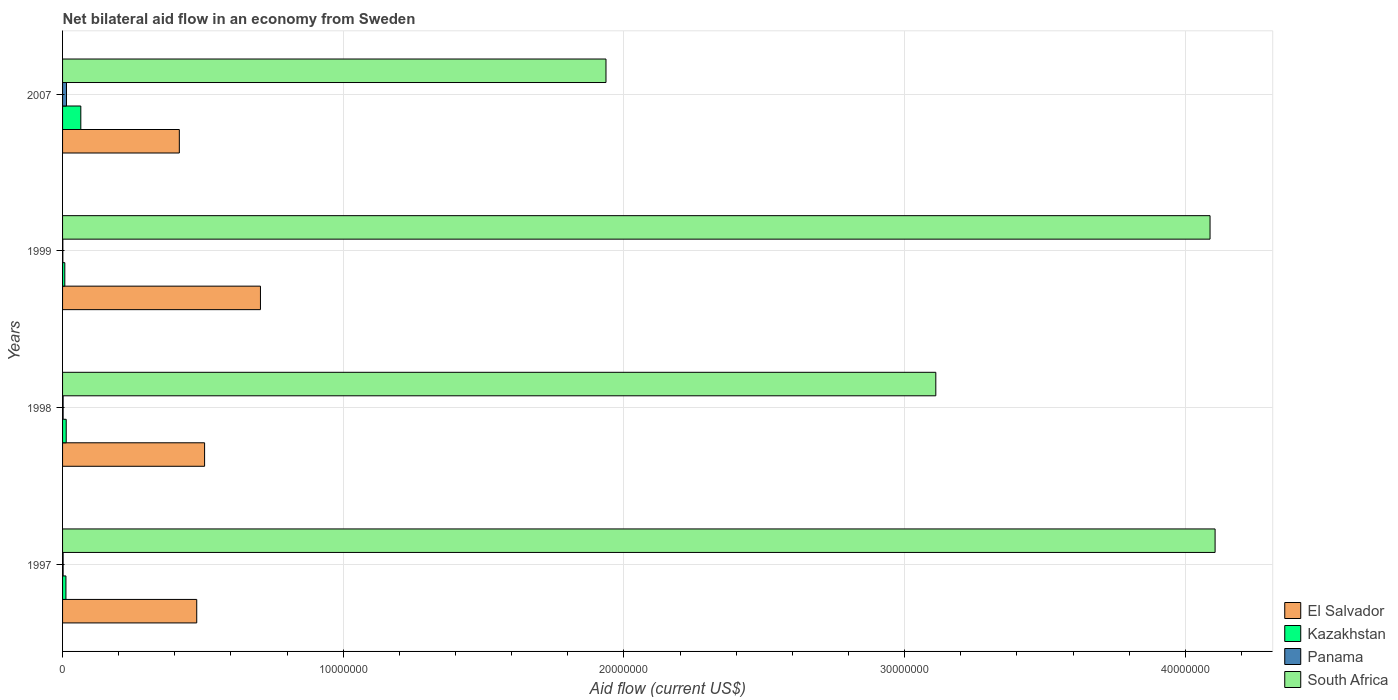How many bars are there on the 1st tick from the bottom?
Offer a very short reply. 4. What is the net bilateral aid flow in El Salvador in 1998?
Provide a succinct answer. 5.06e+06. Across all years, what is the maximum net bilateral aid flow in Panama?
Provide a succinct answer. 1.40e+05. What is the total net bilateral aid flow in Kazakhstan in the graph?
Provide a succinct answer. 9.80e+05. What is the difference between the net bilateral aid flow in South Africa in 1998 and the net bilateral aid flow in Kazakhstan in 1997?
Give a very brief answer. 3.10e+07. What is the average net bilateral aid flow in South Africa per year?
Give a very brief answer. 3.31e+07. In the year 1998, what is the difference between the net bilateral aid flow in Kazakhstan and net bilateral aid flow in El Salvador?
Your response must be concise. -4.93e+06. What is the ratio of the net bilateral aid flow in El Salvador in 1997 to that in 2007?
Ensure brevity in your answer.  1.15. Is the difference between the net bilateral aid flow in Kazakhstan in 1997 and 1999 greater than the difference between the net bilateral aid flow in El Salvador in 1997 and 1999?
Provide a succinct answer. Yes. What is the difference between the highest and the second highest net bilateral aid flow in Panama?
Ensure brevity in your answer.  1.20e+05. What is the difference between the highest and the lowest net bilateral aid flow in South Africa?
Make the answer very short. 2.17e+07. Is the sum of the net bilateral aid flow in South Africa in 1999 and 2007 greater than the maximum net bilateral aid flow in El Salvador across all years?
Your answer should be compact. Yes. Is it the case that in every year, the sum of the net bilateral aid flow in Panama and net bilateral aid flow in South Africa is greater than the sum of net bilateral aid flow in El Salvador and net bilateral aid flow in Kazakhstan?
Keep it short and to the point. Yes. What does the 3rd bar from the top in 1999 represents?
Ensure brevity in your answer.  Kazakhstan. What does the 1st bar from the bottom in 1997 represents?
Provide a succinct answer. El Salvador. Is it the case that in every year, the sum of the net bilateral aid flow in El Salvador and net bilateral aid flow in Panama is greater than the net bilateral aid flow in Kazakhstan?
Provide a short and direct response. Yes. Are all the bars in the graph horizontal?
Offer a terse response. Yes. What is the difference between two consecutive major ticks on the X-axis?
Provide a succinct answer. 1.00e+07. Are the values on the major ticks of X-axis written in scientific E-notation?
Keep it short and to the point. No. Does the graph contain any zero values?
Your response must be concise. No. Does the graph contain grids?
Offer a very short reply. Yes. What is the title of the graph?
Make the answer very short. Net bilateral aid flow in an economy from Sweden. What is the label or title of the X-axis?
Provide a short and direct response. Aid flow (current US$). What is the Aid flow (current US$) in El Salvador in 1997?
Offer a very short reply. 4.78e+06. What is the Aid flow (current US$) of South Africa in 1997?
Your answer should be compact. 4.11e+07. What is the Aid flow (current US$) in El Salvador in 1998?
Keep it short and to the point. 5.06e+06. What is the Aid flow (current US$) in Kazakhstan in 1998?
Provide a succinct answer. 1.30e+05. What is the Aid flow (current US$) in South Africa in 1998?
Your answer should be compact. 3.11e+07. What is the Aid flow (current US$) in El Salvador in 1999?
Your response must be concise. 7.05e+06. What is the Aid flow (current US$) in South Africa in 1999?
Offer a very short reply. 4.09e+07. What is the Aid flow (current US$) in El Salvador in 2007?
Give a very brief answer. 4.16e+06. What is the Aid flow (current US$) in Kazakhstan in 2007?
Provide a short and direct response. 6.50e+05. What is the Aid flow (current US$) in South Africa in 2007?
Provide a short and direct response. 1.94e+07. Across all years, what is the maximum Aid flow (current US$) in El Salvador?
Your answer should be very brief. 7.05e+06. Across all years, what is the maximum Aid flow (current US$) of Kazakhstan?
Provide a short and direct response. 6.50e+05. Across all years, what is the maximum Aid flow (current US$) in Panama?
Provide a short and direct response. 1.40e+05. Across all years, what is the maximum Aid flow (current US$) of South Africa?
Keep it short and to the point. 4.11e+07. Across all years, what is the minimum Aid flow (current US$) in El Salvador?
Your answer should be very brief. 4.16e+06. Across all years, what is the minimum Aid flow (current US$) in Kazakhstan?
Offer a terse response. 8.00e+04. Across all years, what is the minimum Aid flow (current US$) of South Africa?
Provide a short and direct response. 1.94e+07. What is the total Aid flow (current US$) in El Salvador in the graph?
Your answer should be very brief. 2.10e+07. What is the total Aid flow (current US$) of Kazakhstan in the graph?
Give a very brief answer. 9.80e+05. What is the total Aid flow (current US$) of Panama in the graph?
Keep it short and to the point. 1.90e+05. What is the total Aid flow (current US$) in South Africa in the graph?
Offer a terse response. 1.32e+08. What is the difference between the Aid flow (current US$) in El Salvador in 1997 and that in 1998?
Your response must be concise. -2.80e+05. What is the difference between the Aid flow (current US$) of Panama in 1997 and that in 1998?
Provide a succinct answer. 0. What is the difference between the Aid flow (current US$) of South Africa in 1997 and that in 1998?
Provide a succinct answer. 9.95e+06. What is the difference between the Aid flow (current US$) in El Salvador in 1997 and that in 1999?
Your response must be concise. -2.27e+06. What is the difference between the Aid flow (current US$) in El Salvador in 1997 and that in 2007?
Provide a short and direct response. 6.20e+05. What is the difference between the Aid flow (current US$) of Kazakhstan in 1997 and that in 2007?
Provide a succinct answer. -5.30e+05. What is the difference between the Aid flow (current US$) in Panama in 1997 and that in 2007?
Offer a terse response. -1.20e+05. What is the difference between the Aid flow (current US$) of South Africa in 1997 and that in 2007?
Ensure brevity in your answer.  2.17e+07. What is the difference between the Aid flow (current US$) of El Salvador in 1998 and that in 1999?
Offer a terse response. -1.99e+06. What is the difference between the Aid flow (current US$) in Kazakhstan in 1998 and that in 1999?
Your response must be concise. 5.00e+04. What is the difference between the Aid flow (current US$) of Panama in 1998 and that in 1999?
Provide a short and direct response. 10000. What is the difference between the Aid flow (current US$) of South Africa in 1998 and that in 1999?
Offer a terse response. -9.77e+06. What is the difference between the Aid flow (current US$) of El Salvador in 1998 and that in 2007?
Make the answer very short. 9.00e+05. What is the difference between the Aid flow (current US$) of Kazakhstan in 1998 and that in 2007?
Offer a terse response. -5.20e+05. What is the difference between the Aid flow (current US$) in Panama in 1998 and that in 2007?
Ensure brevity in your answer.  -1.20e+05. What is the difference between the Aid flow (current US$) in South Africa in 1998 and that in 2007?
Give a very brief answer. 1.18e+07. What is the difference between the Aid flow (current US$) in El Salvador in 1999 and that in 2007?
Ensure brevity in your answer.  2.89e+06. What is the difference between the Aid flow (current US$) of Kazakhstan in 1999 and that in 2007?
Offer a very short reply. -5.70e+05. What is the difference between the Aid flow (current US$) in Panama in 1999 and that in 2007?
Make the answer very short. -1.30e+05. What is the difference between the Aid flow (current US$) in South Africa in 1999 and that in 2007?
Give a very brief answer. 2.15e+07. What is the difference between the Aid flow (current US$) in El Salvador in 1997 and the Aid flow (current US$) in Kazakhstan in 1998?
Your response must be concise. 4.65e+06. What is the difference between the Aid flow (current US$) in El Salvador in 1997 and the Aid flow (current US$) in Panama in 1998?
Your response must be concise. 4.76e+06. What is the difference between the Aid flow (current US$) in El Salvador in 1997 and the Aid flow (current US$) in South Africa in 1998?
Your answer should be very brief. -2.63e+07. What is the difference between the Aid flow (current US$) in Kazakhstan in 1997 and the Aid flow (current US$) in South Africa in 1998?
Make the answer very short. -3.10e+07. What is the difference between the Aid flow (current US$) of Panama in 1997 and the Aid flow (current US$) of South Africa in 1998?
Offer a very short reply. -3.11e+07. What is the difference between the Aid flow (current US$) of El Salvador in 1997 and the Aid flow (current US$) of Kazakhstan in 1999?
Give a very brief answer. 4.70e+06. What is the difference between the Aid flow (current US$) in El Salvador in 1997 and the Aid flow (current US$) in Panama in 1999?
Offer a terse response. 4.77e+06. What is the difference between the Aid flow (current US$) of El Salvador in 1997 and the Aid flow (current US$) of South Africa in 1999?
Give a very brief answer. -3.61e+07. What is the difference between the Aid flow (current US$) of Kazakhstan in 1997 and the Aid flow (current US$) of South Africa in 1999?
Your response must be concise. -4.08e+07. What is the difference between the Aid flow (current US$) in Panama in 1997 and the Aid flow (current US$) in South Africa in 1999?
Your answer should be compact. -4.09e+07. What is the difference between the Aid flow (current US$) in El Salvador in 1997 and the Aid flow (current US$) in Kazakhstan in 2007?
Provide a short and direct response. 4.13e+06. What is the difference between the Aid flow (current US$) of El Salvador in 1997 and the Aid flow (current US$) of Panama in 2007?
Your answer should be compact. 4.64e+06. What is the difference between the Aid flow (current US$) of El Salvador in 1997 and the Aid flow (current US$) of South Africa in 2007?
Offer a terse response. -1.46e+07. What is the difference between the Aid flow (current US$) of Kazakhstan in 1997 and the Aid flow (current US$) of South Africa in 2007?
Make the answer very short. -1.92e+07. What is the difference between the Aid flow (current US$) in Panama in 1997 and the Aid flow (current US$) in South Africa in 2007?
Your answer should be compact. -1.93e+07. What is the difference between the Aid flow (current US$) in El Salvador in 1998 and the Aid flow (current US$) in Kazakhstan in 1999?
Make the answer very short. 4.98e+06. What is the difference between the Aid flow (current US$) in El Salvador in 1998 and the Aid flow (current US$) in Panama in 1999?
Offer a very short reply. 5.05e+06. What is the difference between the Aid flow (current US$) of El Salvador in 1998 and the Aid flow (current US$) of South Africa in 1999?
Your answer should be very brief. -3.58e+07. What is the difference between the Aid flow (current US$) in Kazakhstan in 1998 and the Aid flow (current US$) in South Africa in 1999?
Make the answer very short. -4.08e+07. What is the difference between the Aid flow (current US$) in Panama in 1998 and the Aid flow (current US$) in South Africa in 1999?
Offer a terse response. -4.09e+07. What is the difference between the Aid flow (current US$) in El Salvador in 1998 and the Aid flow (current US$) in Kazakhstan in 2007?
Your answer should be very brief. 4.41e+06. What is the difference between the Aid flow (current US$) in El Salvador in 1998 and the Aid flow (current US$) in Panama in 2007?
Offer a terse response. 4.92e+06. What is the difference between the Aid flow (current US$) of El Salvador in 1998 and the Aid flow (current US$) of South Africa in 2007?
Give a very brief answer. -1.43e+07. What is the difference between the Aid flow (current US$) in Kazakhstan in 1998 and the Aid flow (current US$) in Panama in 2007?
Provide a short and direct response. -10000. What is the difference between the Aid flow (current US$) of Kazakhstan in 1998 and the Aid flow (current US$) of South Africa in 2007?
Provide a short and direct response. -1.92e+07. What is the difference between the Aid flow (current US$) in Panama in 1998 and the Aid flow (current US$) in South Africa in 2007?
Keep it short and to the point. -1.93e+07. What is the difference between the Aid flow (current US$) in El Salvador in 1999 and the Aid flow (current US$) in Kazakhstan in 2007?
Your response must be concise. 6.40e+06. What is the difference between the Aid flow (current US$) of El Salvador in 1999 and the Aid flow (current US$) of Panama in 2007?
Provide a short and direct response. 6.91e+06. What is the difference between the Aid flow (current US$) in El Salvador in 1999 and the Aid flow (current US$) in South Africa in 2007?
Your answer should be compact. -1.23e+07. What is the difference between the Aid flow (current US$) of Kazakhstan in 1999 and the Aid flow (current US$) of South Africa in 2007?
Ensure brevity in your answer.  -1.93e+07. What is the difference between the Aid flow (current US$) of Panama in 1999 and the Aid flow (current US$) of South Africa in 2007?
Make the answer very short. -1.94e+07. What is the average Aid flow (current US$) of El Salvador per year?
Offer a terse response. 5.26e+06. What is the average Aid flow (current US$) in Kazakhstan per year?
Make the answer very short. 2.45e+05. What is the average Aid flow (current US$) of Panama per year?
Ensure brevity in your answer.  4.75e+04. What is the average Aid flow (current US$) of South Africa per year?
Ensure brevity in your answer.  3.31e+07. In the year 1997, what is the difference between the Aid flow (current US$) in El Salvador and Aid flow (current US$) in Kazakhstan?
Keep it short and to the point. 4.66e+06. In the year 1997, what is the difference between the Aid flow (current US$) in El Salvador and Aid flow (current US$) in Panama?
Provide a short and direct response. 4.76e+06. In the year 1997, what is the difference between the Aid flow (current US$) in El Salvador and Aid flow (current US$) in South Africa?
Your answer should be very brief. -3.63e+07. In the year 1997, what is the difference between the Aid flow (current US$) of Kazakhstan and Aid flow (current US$) of Panama?
Offer a terse response. 1.00e+05. In the year 1997, what is the difference between the Aid flow (current US$) of Kazakhstan and Aid flow (current US$) of South Africa?
Provide a succinct answer. -4.09e+07. In the year 1997, what is the difference between the Aid flow (current US$) in Panama and Aid flow (current US$) in South Africa?
Provide a short and direct response. -4.10e+07. In the year 1998, what is the difference between the Aid flow (current US$) of El Salvador and Aid flow (current US$) of Kazakhstan?
Your response must be concise. 4.93e+06. In the year 1998, what is the difference between the Aid flow (current US$) in El Salvador and Aid flow (current US$) in Panama?
Make the answer very short. 5.04e+06. In the year 1998, what is the difference between the Aid flow (current US$) in El Salvador and Aid flow (current US$) in South Africa?
Keep it short and to the point. -2.60e+07. In the year 1998, what is the difference between the Aid flow (current US$) in Kazakhstan and Aid flow (current US$) in South Africa?
Make the answer very short. -3.10e+07. In the year 1998, what is the difference between the Aid flow (current US$) in Panama and Aid flow (current US$) in South Africa?
Make the answer very short. -3.11e+07. In the year 1999, what is the difference between the Aid flow (current US$) of El Salvador and Aid flow (current US$) of Kazakhstan?
Give a very brief answer. 6.97e+06. In the year 1999, what is the difference between the Aid flow (current US$) of El Salvador and Aid flow (current US$) of Panama?
Keep it short and to the point. 7.04e+06. In the year 1999, what is the difference between the Aid flow (current US$) in El Salvador and Aid flow (current US$) in South Africa?
Offer a terse response. -3.38e+07. In the year 1999, what is the difference between the Aid flow (current US$) in Kazakhstan and Aid flow (current US$) in South Africa?
Offer a terse response. -4.08e+07. In the year 1999, what is the difference between the Aid flow (current US$) of Panama and Aid flow (current US$) of South Africa?
Your answer should be very brief. -4.09e+07. In the year 2007, what is the difference between the Aid flow (current US$) of El Salvador and Aid flow (current US$) of Kazakhstan?
Offer a terse response. 3.51e+06. In the year 2007, what is the difference between the Aid flow (current US$) of El Salvador and Aid flow (current US$) of Panama?
Ensure brevity in your answer.  4.02e+06. In the year 2007, what is the difference between the Aid flow (current US$) in El Salvador and Aid flow (current US$) in South Africa?
Provide a succinct answer. -1.52e+07. In the year 2007, what is the difference between the Aid flow (current US$) of Kazakhstan and Aid flow (current US$) of Panama?
Your answer should be very brief. 5.10e+05. In the year 2007, what is the difference between the Aid flow (current US$) in Kazakhstan and Aid flow (current US$) in South Africa?
Offer a very short reply. -1.87e+07. In the year 2007, what is the difference between the Aid flow (current US$) of Panama and Aid flow (current US$) of South Africa?
Offer a terse response. -1.92e+07. What is the ratio of the Aid flow (current US$) in El Salvador in 1997 to that in 1998?
Your answer should be compact. 0.94. What is the ratio of the Aid flow (current US$) of Panama in 1997 to that in 1998?
Give a very brief answer. 1. What is the ratio of the Aid flow (current US$) of South Africa in 1997 to that in 1998?
Your answer should be very brief. 1.32. What is the ratio of the Aid flow (current US$) of El Salvador in 1997 to that in 1999?
Ensure brevity in your answer.  0.68. What is the ratio of the Aid flow (current US$) of Kazakhstan in 1997 to that in 1999?
Your answer should be very brief. 1.5. What is the ratio of the Aid flow (current US$) of El Salvador in 1997 to that in 2007?
Keep it short and to the point. 1.15. What is the ratio of the Aid flow (current US$) of Kazakhstan in 1997 to that in 2007?
Offer a very short reply. 0.18. What is the ratio of the Aid flow (current US$) of Panama in 1997 to that in 2007?
Make the answer very short. 0.14. What is the ratio of the Aid flow (current US$) of South Africa in 1997 to that in 2007?
Offer a very short reply. 2.12. What is the ratio of the Aid flow (current US$) in El Salvador in 1998 to that in 1999?
Keep it short and to the point. 0.72. What is the ratio of the Aid flow (current US$) in Kazakhstan in 1998 to that in 1999?
Give a very brief answer. 1.62. What is the ratio of the Aid flow (current US$) in Panama in 1998 to that in 1999?
Your answer should be very brief. 2. What is the ratio of the Aid flow (current US$) in South Africa in 1998 to that in 1999?
Offer a very short reply. 0.76. What is the ratio of the Aid flow (current US$) in El Salvador in 1998 to that in 2007?
Make the answer very short. 1.22. What is the ratio of the Aid flow (current US$) in Kazakhstan in 1998 to that in 2007?
Make the answer very short. 0.2. What is the ratio of the Aid flow (current US$) of Panama in 1998 to that in 2007?
Provide a succinct answer. 0.14. What is the ratio of the Aid flow (current US$) in South Africa in 1998 to that in 2007?
Offer a terse response. 1.61. What is the ratio of the Aid flow (current US$) in El Salvador in 1999 to that in 2007?
Your response must be concise. 1.69. What is the ratio of the Aid flow (current US$) of Kazakhstan in 1999 to that in 2007?
Provide a short and direct response. 0.12. What is the ratio of the Aid flow (current US$) in Panama in 1999 to that in 2007?
Your answer should be very brief. 0.07. What is the ratio of the Aid flow (current US$) in South Africa in 1999 to that in 2007?
Provide a succinct answer. 2.11. What is the difference between the highest and the second highest Aid flow (current US$) of El Salvador?
Provide a short and direct response. 1.99e+06. What is the difference between the highest and the second highest Aid flow (current US$) of Kazakhstan?
Make the answer very short. 5.20e+05. What is the difference between the highest and the second highest Aid flow (current US$) of South Africa?
Make the answer very short. 1.80e+05. What is the difference between the highest and the lowest Aid flow (current US$) in El Salvador?
Give a very brief answer. 2.89e+06. What is the difference between the highest and the lowest Aid flow (current US$) of Kazakhstan?
Ensure brevity in your answer.  5.70e+05. What is the difference between the highest and the lowest Aid flow (current US$) in Panama?
Give a very brief answer. 1.30e+05. What is the difference between the highest and the lowest Aid flow (current US$) of South Africa?
Provide a succinct answer. 2.17e+07. 